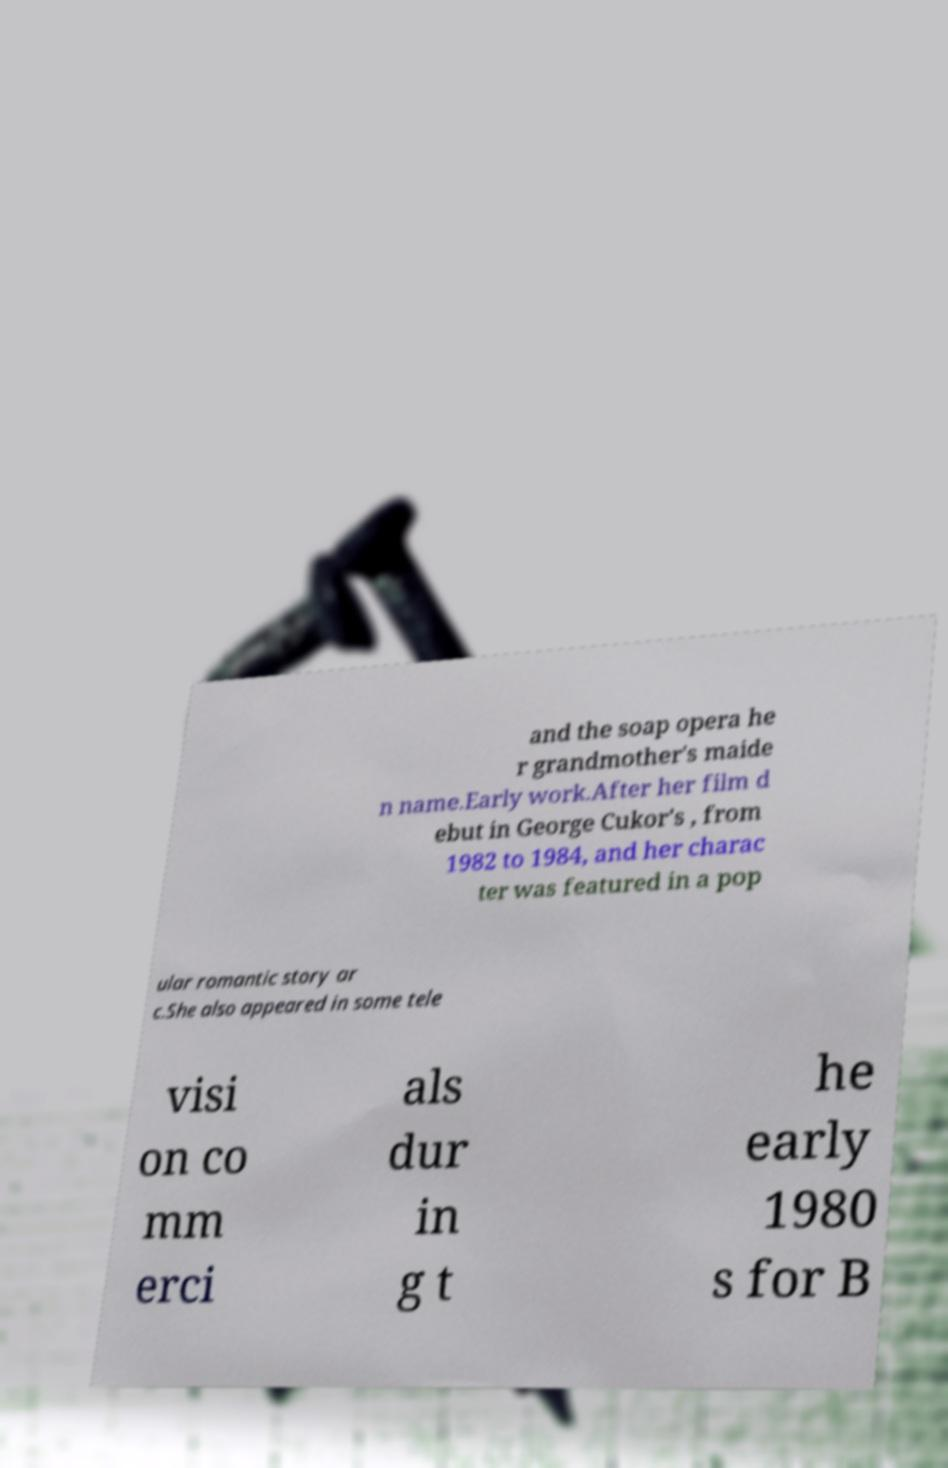Can you accurately transcribe the text from the provided image for me? and the soap opera he r grandmother's maide n name.Early work.After her film d ebut in George Cukor's , from 1982 to 1984, and her charac ter was featured in a pop ular romantic story ar c.She also appeared in some tele visi on co mm erci als dur in g t he early 1980 s for B 